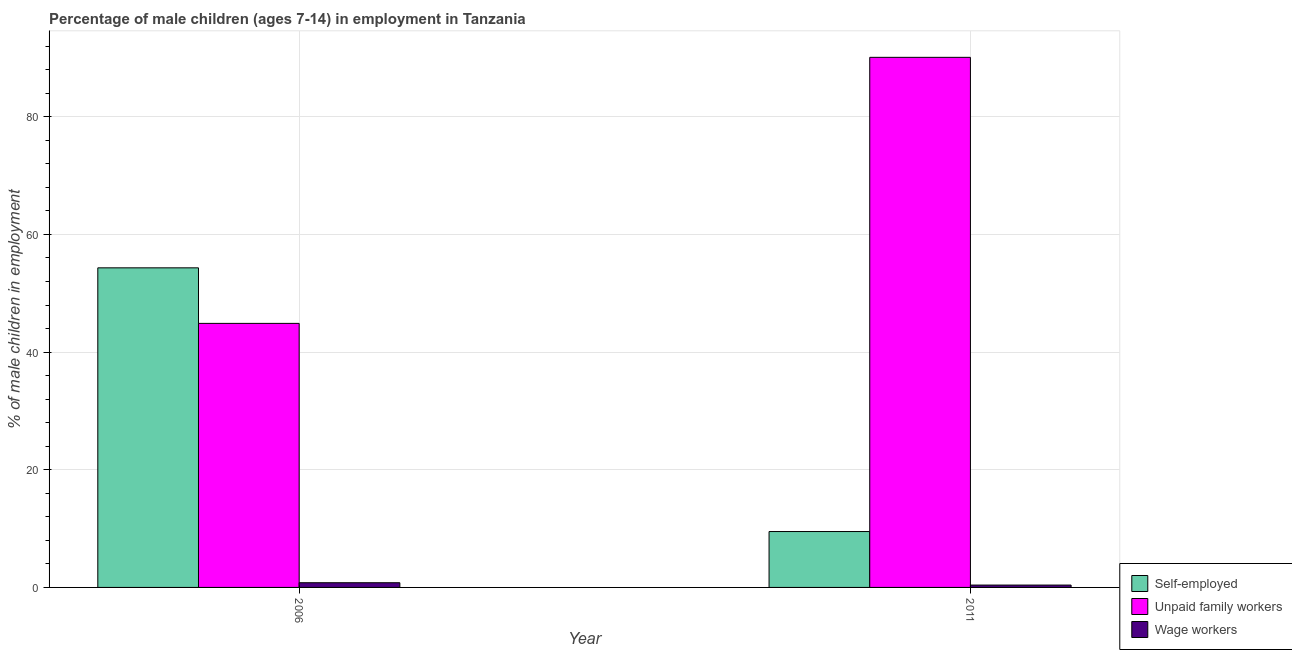How many different coloured bars are there?
Your response must be concise. 3. Are the number of bars on each tick of the X-axis equal?
Give a very brief answer. Yes. How many bars are there on the 2nd tick from the right?
Your response must be concise. 3. In how many cases, is the number of bars for a given year not equal to the number of legend labels?
Your response must be concise. 0. What is the percentage of children employed as unpaid family workers in 2011?
Offer a terse response. 90.1. Across all years, what is the maximum percentage of children employed as unpaid family workers?
Your answer should be compact. 90.1. Across all years, what is the minimum percentage of children employed as unpaid family workers?
Your response must be concise. 44.88. What is the total percentage of children employed as wage workers in the graph?
Your response must be concise. 1.2. What is the difference between the percentage of children employed as unpaid family workers in 2006 and that in 2011?
Make the answer very short. -45.22. What is the difference between the percentage of children employed as unpaid family workers in 2011 and the percentage of children employed as wage workers in 2006?
Your response must be concise. 45.22. What is the average percentage of children employed as unpaid family workers per year?
Ensure brevity in your answer.  67.49. In how many years, is the percentage of children employed as wage workers greater than 36 %?
Offer a very short reply. 0. What is the ratio of the percentage of children employed as unpaid family workers in 2006 to that in 2011?
Give a very brief answer. 0.5. What does the 1st bar from the left in 2011 represents?
Keep it short and to the point. Self-employed. What does the 2nd bar from the right in 2006 represents?
Offer a terse response. Unpaid family workers. Is it the case that in every year, the sum of the percentage of self employed children and percentage of children employed as unpaid family workers is greater than the percentage of children employed as wage workers?
Your response must be concise. Yes. How many years are there in the graph?
Provide a succinct answer. 2. Does the graph contain any zero values?
Ensure brevity in your answer.  No. Does the graph contain grids?
Offer a terse response. Yes. What is the title of the graph?
Your response must be concise. Percentage of male children (ages 7-14) in employment in Tanzania. What is the label or title of the X-axis?
Offer a terse response. Year. What is the label or title of the Y-axis?
Provide a succinct answer. % of male children in employment. What is the % of male children in employment in Self-employed in 2006?
Make the answer very short. 54.32. What is the % of male children in employment in Unpaid family workers in 2006?
Your response must be concise. 44.88. What is the % of male children in employment in Self-employed in 2011?
Your response must be concise. 9.5. What is the % of male children in employment in Unpaid family workers in 2011?
Keep it short and to the point. 90.1. What is the % of male children in employment in Wage workers in 2011?
Offer a very short reply. 0.4. Across all years, what is the maximum % of male children in employment in Self-employed?
Your answer should be compact. 54.32. Across all years, what is the maximum % of male children in employment in Unpaid family workers?
Provide a succinct answer. 90.1. Across all years, what is the maximum % of male children in employment in Wage workers?
Provide a short and direct response. 0.8. Across all years, what is the minimum % of male children in employment of Unpaid family workers?
Make the answer very short. 44.88. What is the total % of male children in employment of Self-employed in the graph?
Keep it short and to the point. 63.82. What is the total % of male children in employment of Unpaid family workers in the graph?
Offer a terse response. 134.98. What is the total % of male children in employment of Wage workers in the graph?
Make the answer very short. 1.2. What is the difference between the % of male children in employment of Self-employed in 2006 and that in 2011?
Provide a short and direct response. 44.82. What is the difference between the % of male children in employment of Unpaid family workers in 2006 and that in 2011?
Offer a very short reply. -45.22. What is the difference between the % of male children in employment in Self-employed in 2006 and the % of male children in employment in Unpaid family workers in 2011?
Give a very brief answer. -35.78. What is the difference between the % of male children in employment in Self-employed in 2006 and the % of male children in employment in Wage workers in 2011?
Keep it short and to the point. 53.92. What is the difference between the % of male children in employment of Unpaid family workers in 2006 and the % of male children in employment of Wage workers in 2011?
Provide a short and direct response. 44.48. What is the average % of male children in employment of Self-employed per year?
Offer a very short reply. 31.91. What is the average % of male children in employment in Unpaid family workers per year?
Your response must be concise. 67.49. What is the average % of male children in employment of Wage workers per year?
Ensure brevity in your answer.  0.6. In the year 2006, what is the difference between the % of male children in employment of Self-employed and % of male children in employment of Unpaid family workers?
Provide a succinct answer. 9.44. In the year 2006, what is the difference between the % of male children in employment in Self-employed and % of male children in employment in Wage workers?
Provide a succinct answer. 53.52. In the year 2006, what is the difference between the % of male children in employment in Unpaid family workers and % of male children in employment in Wage workers?
Your answer should be very brief. 44.08. In the year 2011, what is the difference between the % of male children in employment in Self-employed and % of male children in employment in Unpaid family workers?
Your answer should be very brief. -80.6. In the year 2011, what is the difference between the % of male children in employment in Self-employed and % of male children in employment in Wage workers?
Give a very brief answer. 9.1. In the year 2011, what is the difference between the % of male children in employment of Unpaid family workers and % of male children in employment of Wage workers?
Keep it short and to the point. 89.7. What is the ratio of the % of male children in employment in Self-employed in 2006 to that in 2011?
Make the answer very short. 5.72. What is the ratio of the % of male children in employment in Unpaid family workers in 2006 to that in 2011?
Offer a terse response. 0.5. What is the ratio of the % of male children in employment of Wage workers in 2006 to that in 2011?
Provide a succinct answer. 2. What is the difference between the highest and the second highest % of male children in employment in Self-employed?
Provide a short and direct response. 44.82. What is the difference between the highest and the second highest % of male children in employment of Unpaid family workers?
Offer a very short reply. 45.22. What is the difference between the highest and the second highest % of male children in employment in Wage workers?
Provide a short and direct response. 0.4. What is the difference between the highest and the lowest % of male children in employment of Self-employed?
Provide a succinct answer. 44.82. What is the difference between the highest and the lowest % of male children in employment of Unpaid family workers?
Ensure brevity in your answer.  45.22. 